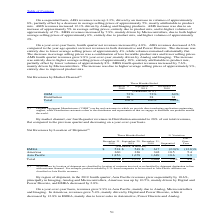According to Stmicroelectronics's financial document, What caused the increase in Asia Pacific revenues in fourth quarter of 2019? Imaging, Analog and Microcontrollers, Americas was up by 10.5%, mainly driven by Digital and Power Discrete, and EMEA decreased by 2.0%.. The document states: "evenues grew sequentially by 10.6%, principally in Imaging, Analog and Microcontrollers, Americas was up by 10.5%, mainly driven by Digital and Power ..." Also, What was the year-over-year increase in revenue for Asia? According to the financial document, 9.9%. The relevant text states: "r selling prices. AMS fourth quarter revenues grew 9.9% year-over-year, mainly driven by Analog and Imaging. The increase was entirely due to higher average..." Also, What caused the year-over-year increase in Revenue for Asia? mainly due to Analog, Microcontrollers and Imaging.. The document states: "er-year basis, revenues grew 9.9% in Asia Pacific, mainly due to Analog, Microcontrollers and Imaging. In Americas, revenues grew 5.4%, mainly driven ..." Also, can you calculate: What is the increase / (decrease) in the EMEA revenue from 2018 to 2019? Based on the calculation: 538 - 617, the result is -79 (in millions). This is based on the information: "EMEA $ 538 $ 549 $ 617 (2.0)% (12.8)% EMEA $ 538 $ 549 $ 617 (2.0)% (12.8)%..." The key data points involved are: 538, 617. Also, can you calculate: What is the average Americas revenue in 2019 and 2018? To answer this question, I need to perform calculations using the financial data. The calculation is: (360 + 342) / 2, which equals 351 (in millions). This is based on the information: "Americas 360 326 342 10.5 5.4 Americas 360 326 342 10.5 5.4..." The key data points involved are: 342, 360. Also, can you calculate: What is the increase / (decrease) in the total revenue from 2018 to 2019? Based on the calculation: 2,754 - 2,648, the result is 106 (in millions). This is based on the information: "Total $ 2,754 $ 2,553 $ 2,648 7.9% 4.0% Total $ 2,754 $ 2,553 $ 2,648 7.9% 4.0%..." The key data points involved are: 2,648, 2,754. 